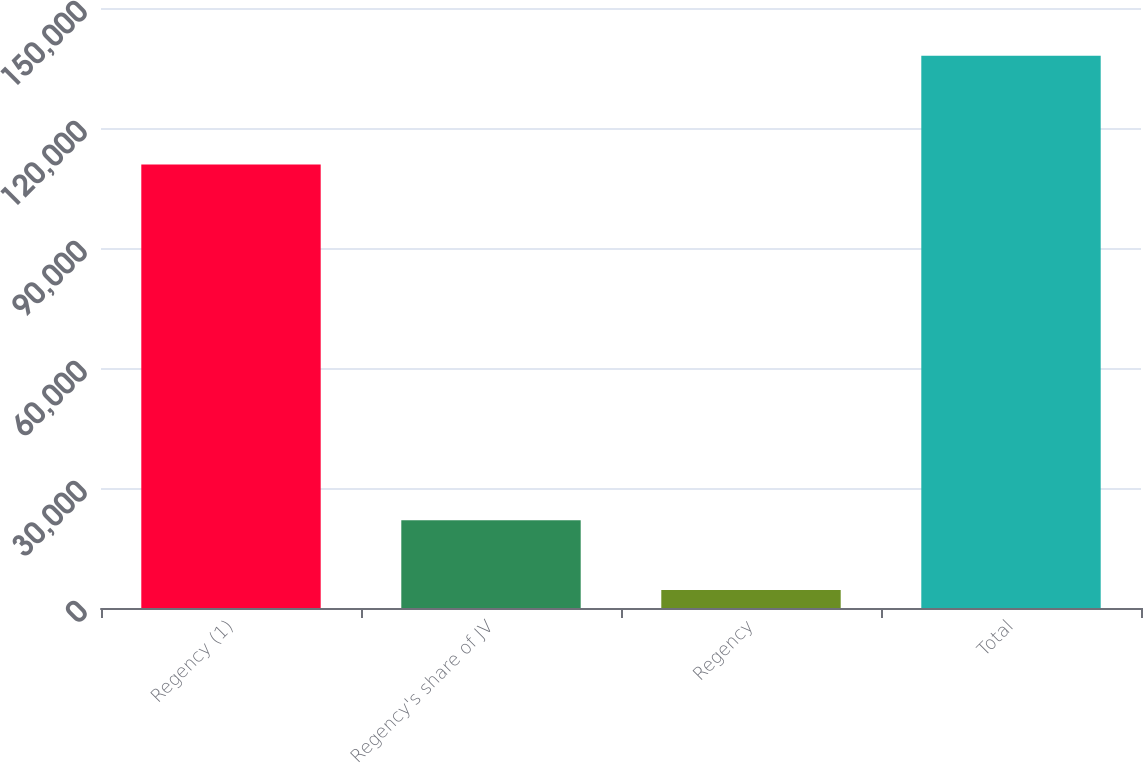Convert chart. <chart><loc_0><loc_0><loc_500><loc_500><bar_chart><fcel>Regency (1)<fcel>Regency's share of JV<fcel>Regency<fcel>Total<nl><fcel>110879<fcel>21918<fcel>4478<fcel>138070<nl></chart> 